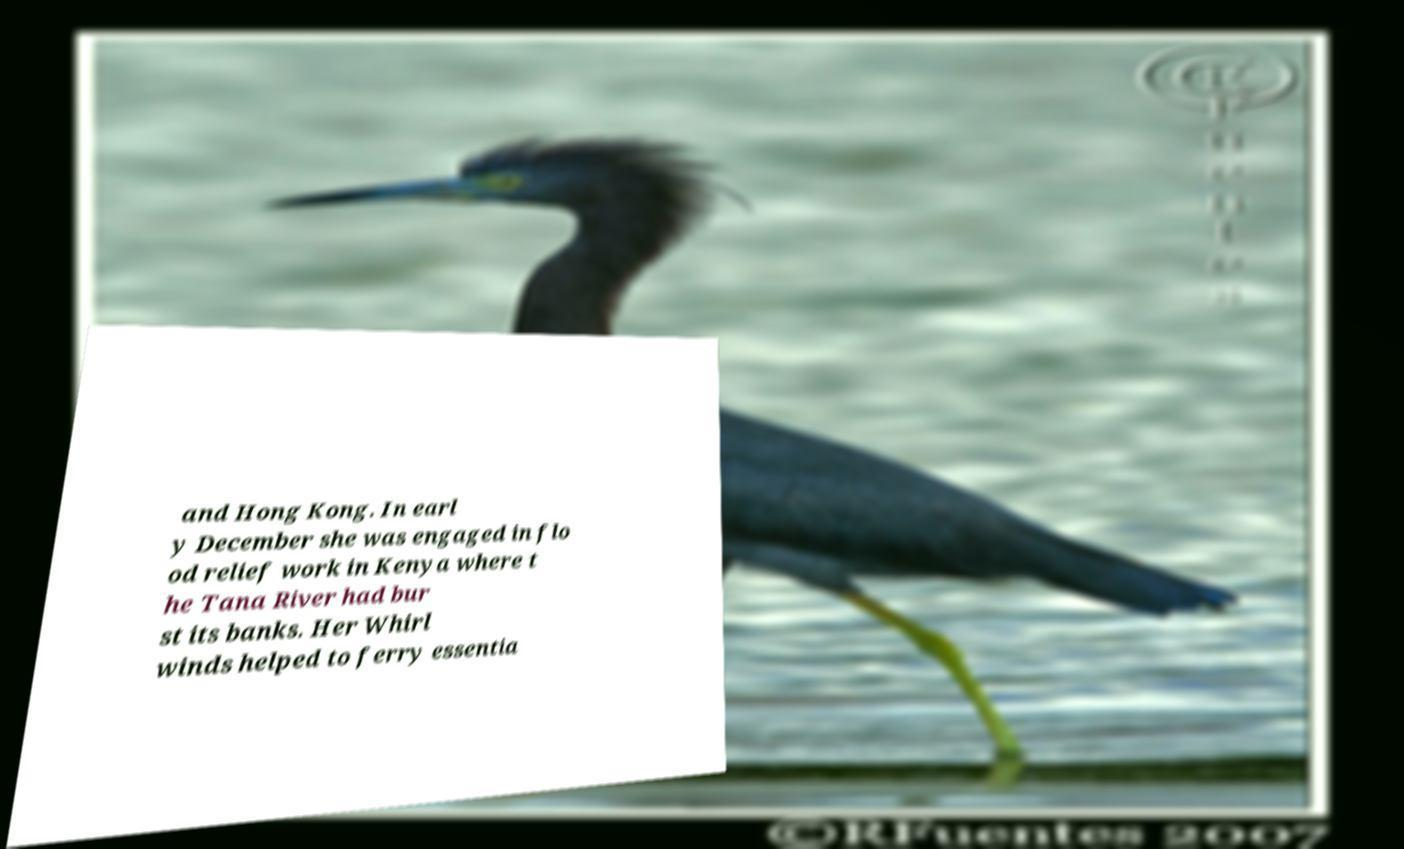What messages or text are displayed in this image? I need them in a readable, typed format. and Hong Kong. In earl y December she was engaged in flo od relief work in Kenya where t he Tana River had bur st its banks. Her Whirl winds helped to ferry essentia 